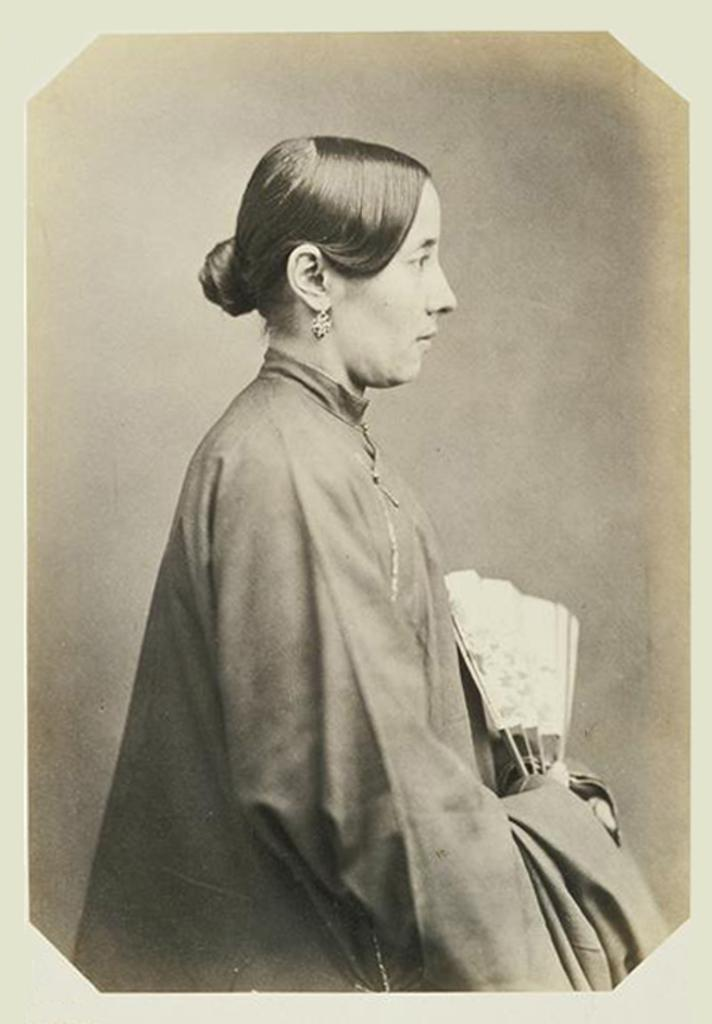What is the color scheme of the image? The image is black and white. Who is present in the image? There is a woman in the image. What is the woman doing in the image? The woman is standing and facing towards the right side. What is the woman holding in her hands? The woman is holding a white color object in her hands. Has the image been altered in any way? Yes, the image has been edited. What type of spring can be seen in the image? There is no spring present in the image. What offer is the woman making in the image? The image does not depict the woman making any offer; she is simply standing and holding a white object. 